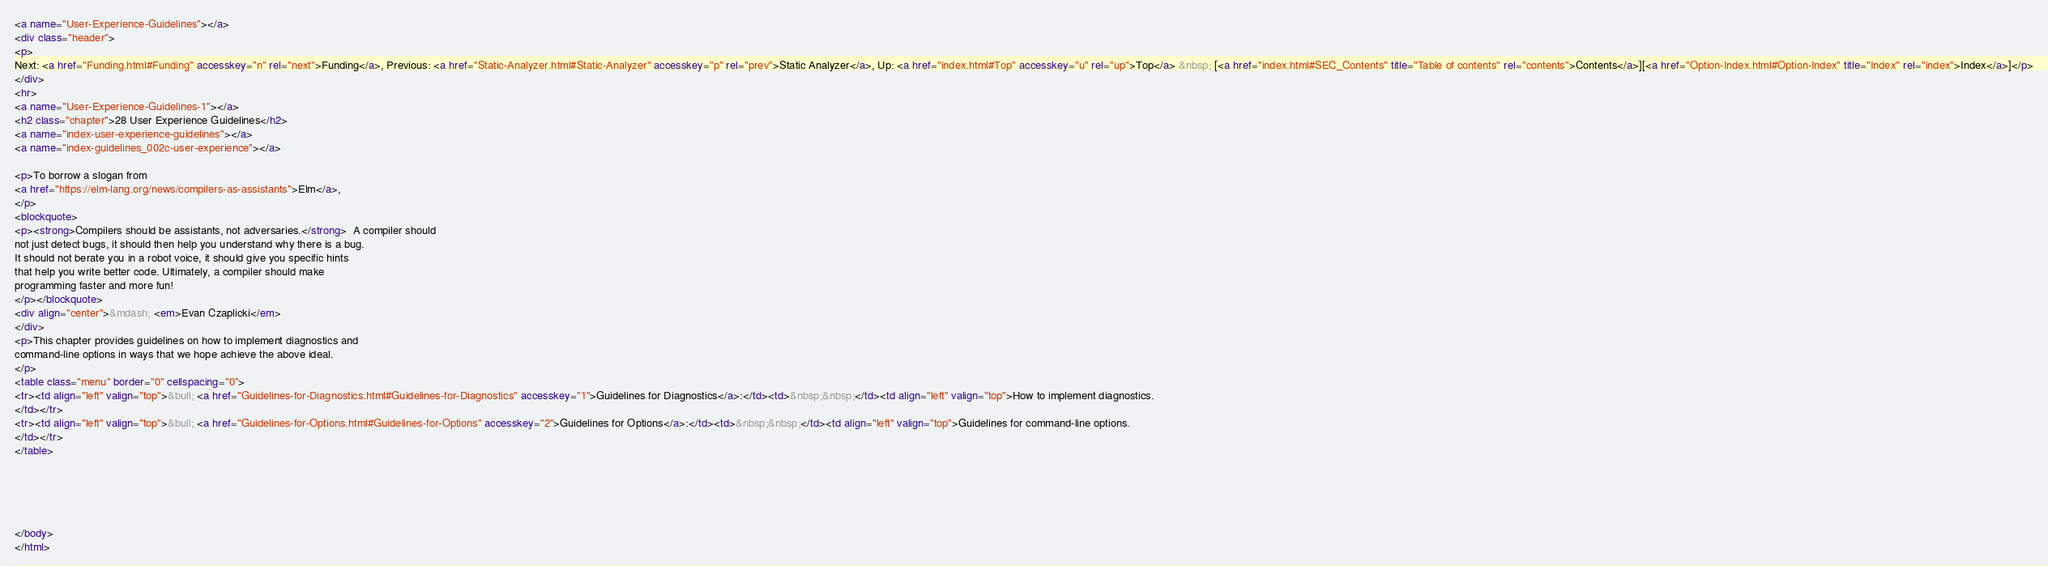<code> <loc_0><loc_0><loc_500><loc_500><_HTML_><a name="User-Experience-Guidelines"></a>
<div class="header">
<p>
Next: <a href="Funding.html#Funding" accesskey="n" rel="next">Funding</a>, Previous: <a href="Static-Analyzer.html#Static-Analyzer" accesskey="p" rel="prev">Static Analyzer</a>, Up: <a href="index.html#Top" accesskey="u" rel="up">Top</a> &nbsp; [<a href="index.html#SEC_Contents" title="Table of contents" rel="contents">Contents</a>][<a href="Option-Index.html#Option-Index" title="Index" rel="index">Index</a>]</p>
</div>
<hr>
<a name="User-Experience-Guidelines-1"></a>
<h2 class="chapter">28 User Experience Guidelines</h2>
<a name="index-user-experience-guidelines"></a>
<a name="index-guidelines_002c-user-experience"></a>

<p>To borrow a slogan from
<a href="https://elm-lang.org/news/compilers-as-assistants">Elm</a>,
</p>
<blockquote>
<p><strong>Compilers should be assistants, not adversaries.</strong>  A compiler should
not just detect bugs, it should then help you understand why there is a bug.
It should not berate you in a robot voice, it should give you specific hints
that help you write better code. Ultimately, a compiler should make
programming faster and more fun!
</p></blockquote>
<div align="center">&mdash; <em>Evan Czaplicki</em>
</div>
<p>This chapter provides guidelines on how to implement diagnostics and
command-line options in ways that we hope achieve the above ideal.
</p>
<table class="menu" border="0" cellspacing="0">
<tr><td align="left" valign="top">&bull; <a href="Guidelines-for-Diagnostics.html#Guidelines-for-Diagnostics" accesskey="1">Guidelines for Diagnostics</a>:</td><td>&nbsp;&nbsp;</td><td align="left" valign="top">How to implement diagnostics.
</td></tr>
<tr><td align="left" valign="top">&bull; <a href="Guidelines-for-Options.html#Guidelines-for-Options" accesskey="2">Guidelines for Options</a>:</td><td>&nbsp;&nbsp;</td><td align="left" valign="top">Guidelines for command-line options.
</td></tr>
</table>





</body>
</html>
</code> 